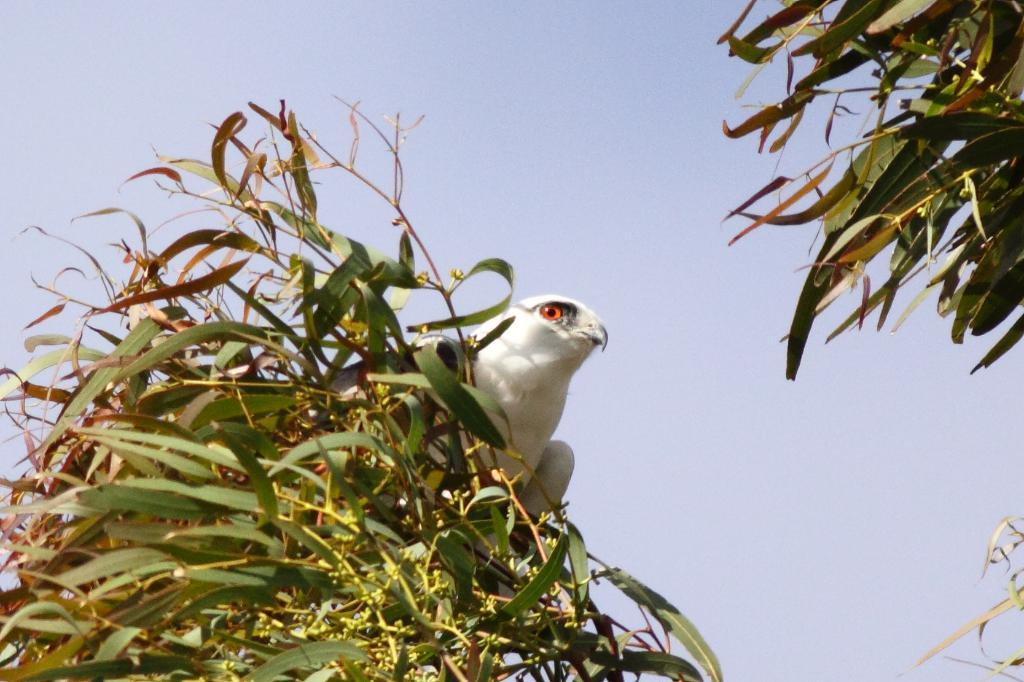What animal can be seen in the image? There is a bird in the image. Where is the bird located in the image? The bird is sitting on a branch of a tree. What type of vegetation is present in the image? There are leaves on both the left and right sides of the image. What is the condition of the sky in the image? The sky is clear in the image. What type of corn is growing on the branch where the bird is sitting? There is no corn present in the image; it features a bird sitting on a branch of a tree with leaves on both sides. 